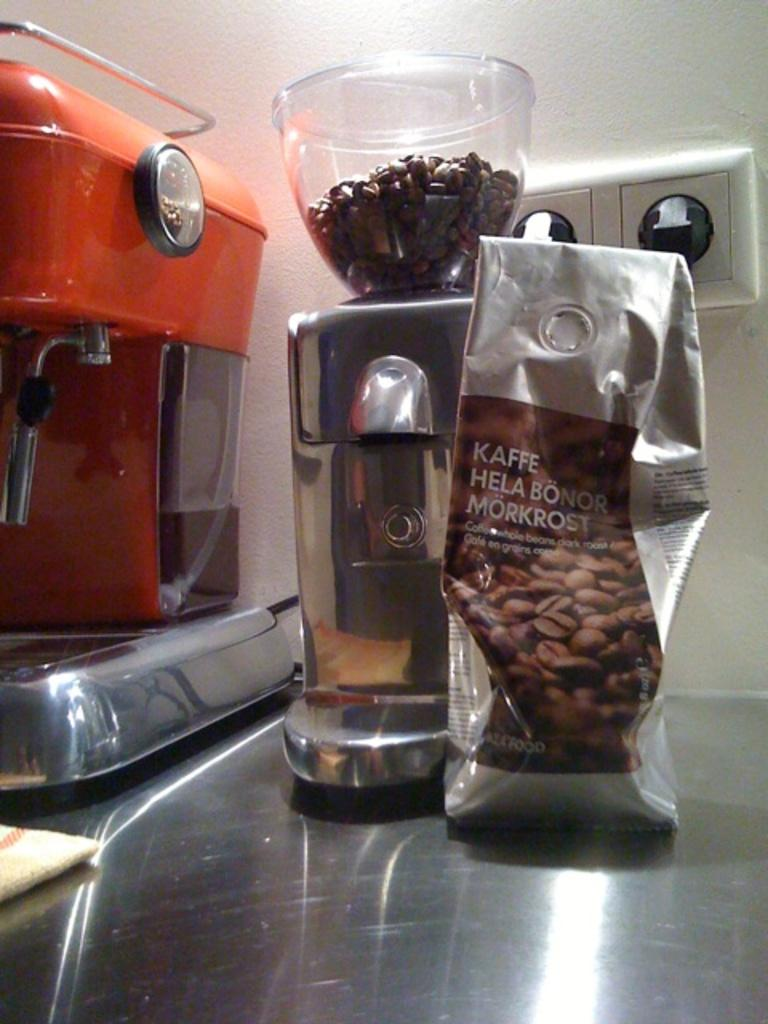<image>
Write a terse but informative summary of the picture. A bag of Kaffe Hela Bonor Morkrost coffee beans is being grinded. 